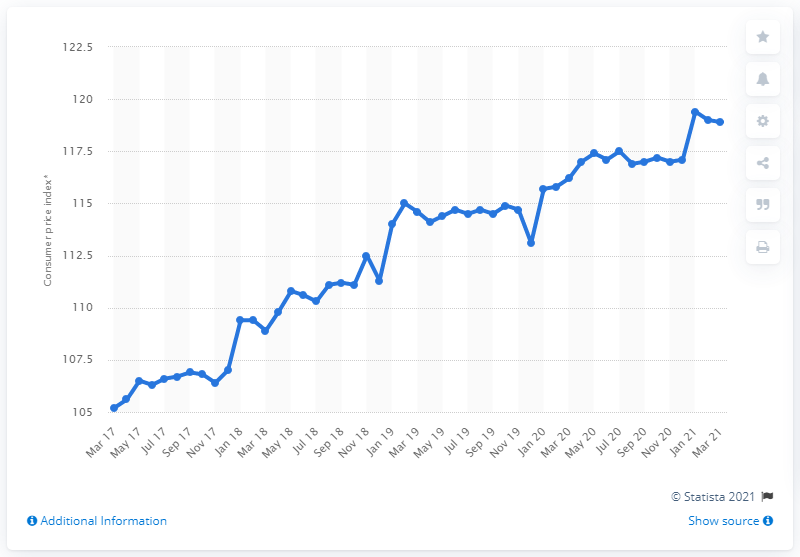Specify some key components in this picture. In March 2021, the CPI of alcoholic beverages and tobacco was 118.9. 